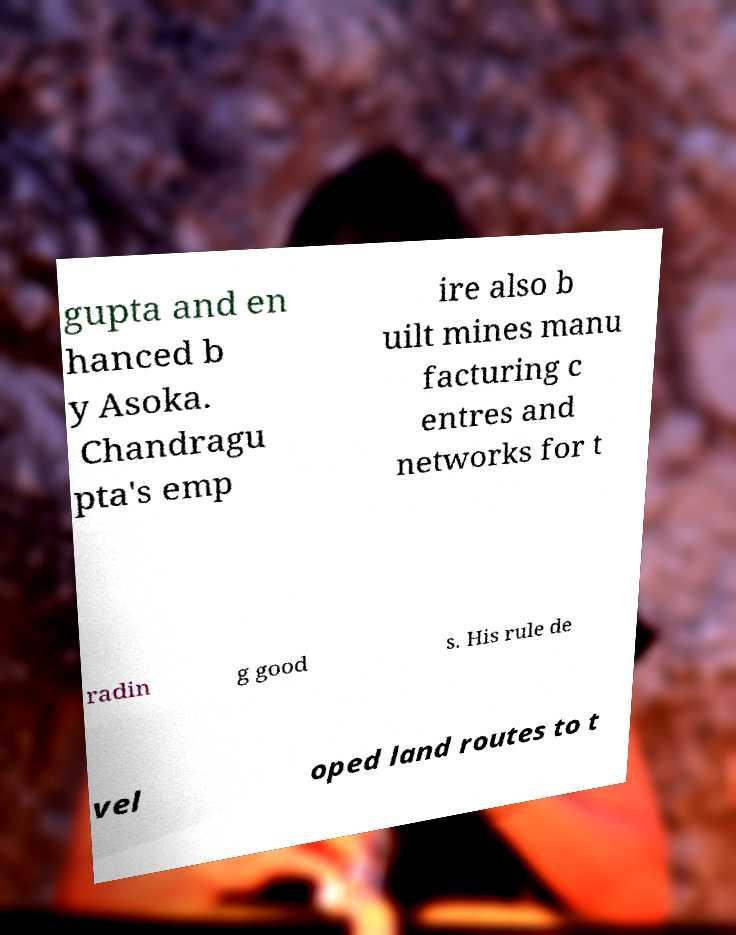For documentation purposes, I need the text within this image transcribed. Could you provide that? gupta and en hanced b y Asoka. Chandragu pta's emp ire also b uilt mines manu facturing c entres and networks for t radin g good s. His rule de vel oped land routes to t 